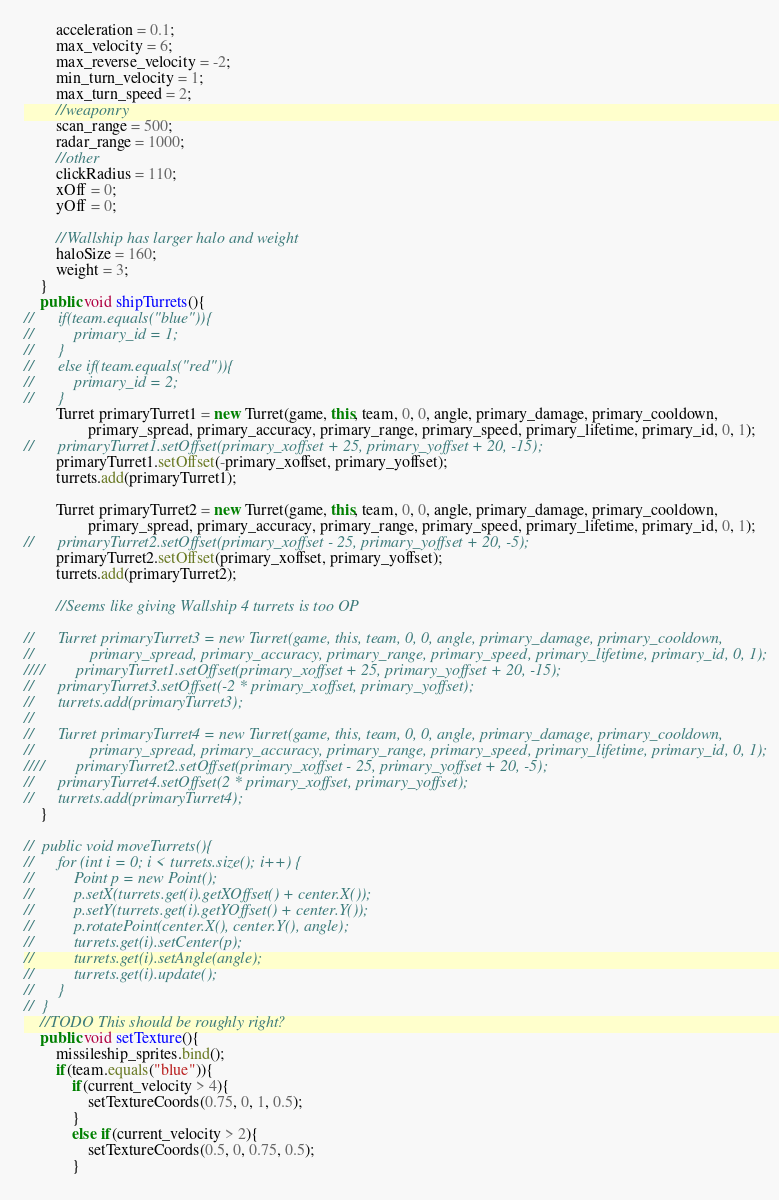Convert code to text. <code><loc_0><loc_0><loc_500><loc_500><_Java_>		acceleration = 0.1;
		max_velocity = 6;
		max_reverse_velocity = -2;
		min_turn_velocity = 1;
		max_turn_speed = 2;
		//weaponry
		scan_range = 500;
		radar_range = 1000;
		//other
		clickRadius = 110;
		xOff = 0;
		yOff = 0;
		
		//Wallship has larger halo and weight
		haloSize = 160;
		weight = 3;
	}
	public void shipTurrets(){
//		if(team.equals("blue")){
//			primary_id = 1;
//		}
//		else if(team.equals("red")){
//			primary_id = 2;
//		}
		Turret primaryTurret1 = new Turret(game, this, team, 0, 0, angle, primary_damage, primary_cooldown, 
				primary_spread, primary_accuracy, primary_range, primary_speed, primary_lifetime, primary_id, 0, 1);
//		primaryTurret1.setOffset(primary_xoffset + 25, primary_yoffset + 20, -15);
		primaryTurret1.setOffset(-primary_xoffset, primary_yoffset);
		turrets.add(primaryTurret1);
		
		Turret primaryTurret2 = new Turret(game, this, team, 0, 0, angle, primary_damage, primary_cooldown, 
				primary_spread, primary_accuracy, primary_range, primary_speed, primary_lifetime, primary_id, 0, 1);
//		primaryTurret2.setOffset(primary_xoffset - 25, primary_yoffset + 20, -5);
		primaryTurret2.setOffset(primary_xoffset, primary_yoffset);
		turrets.add(primaryTurret2);
		
		//Seems like giving Wallship 4 turrets is too OP
		
//		Turret primaryTurret3 = new Turret(game, this, team, 0, 0, angle, primary_damage, primary_cooldown, 
//				primary_spread, primary_accuracy, primary_range, primary_speed, primary_lifetime, primary_id, 0, 1);
////		primaryTurret1.setOffset(primary_xoffset + 25, primary_yoffset + 20, -15);
//		primaryTurret3.setOffset(-2 * primary_xoffset, primary_yoffset);
//		turrets.add(primaryTurret3);
//		
//		Turret primaryTurret4 = new Turret(game, this, team, 0, 0, angle, primary_damage, primary_cooldown, 
//				primary_spread, primary_accuracy, primary_range, primary_speed, primary_lifetime, primary_id, 0, 1);
////		primaryTurret2.setOffset(primary_xoffset - 25, primary_yoffset + 20, -5);
//		primaryTurret4.setOffset(2 * primary_xoffset, primary_yoffset);
//		turrets.add(primaryTurret4);
	}
	
//	public void moveTurrets(){
//		for (int i = 0; i < turrets.size(); i++) {
//			Point p = new Point();
//			p.setX(turrets.get(i).getXOffset() + center.X());
//			p.setY(turrets.get(i).getYOffset() + center.Y());
//			p.rotatePoint(center.X(), center.Y(), angle);
//			turrets.get(i).setCenter(p);
//			turrets.get(i).setAngle(angle);
//			turrets.get(i).update();
//		}
//	}
	//TODO This should be roughly right?
	public void setTexture(){
		missileship_sprites.bind();
		if(team.equals("blue")){
			if(current_velocity > 4){
				setTextureCoords(0.75, 0, 1, 0.5);
			}
			else if(current_velocity > 2){
				setTextureCoords(0.5, 0, 0.75, 0.5);
			}</code> 